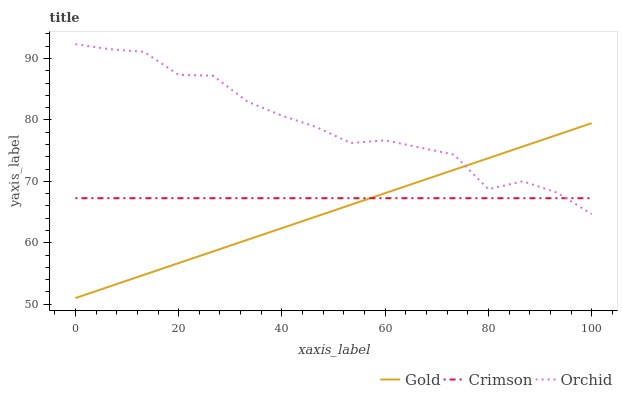Does Gold have the minimum area under the curve?
Answer yes or no. Yes. Does Orchid have the maximum area under the curve?
Answer yes or no. Yes. Does Orchid have the minimum area under the curve?
Answer yes or no. No. Does Gold have the maximum area under the curve?
Answer yes or no. No. Is Gold the smoothest?
Answer yes or no. Yes. Is Orchid the roughest?
Answer yes or no. Yes. Is Orchid the smoothest?
Answer yes or no. No. Is Gold the roughest?
Answer yes or no. No. Does Gold have the lowest value?
Answer yes or no. Yes. Does Orchid have the lowest value?
Answer yes or no. No. Does Orchid have the highest value?
Answer yes or no. Yes. Does Gold have the highest value?
Answer yes or no. No. Does Orchid intersect Crimson?
Answer yes or no. Yes. Is Orchid less than Crimson?
Answer yes or no. No. Is Orchid greater than Crimson?
Answer yes or no. No. 